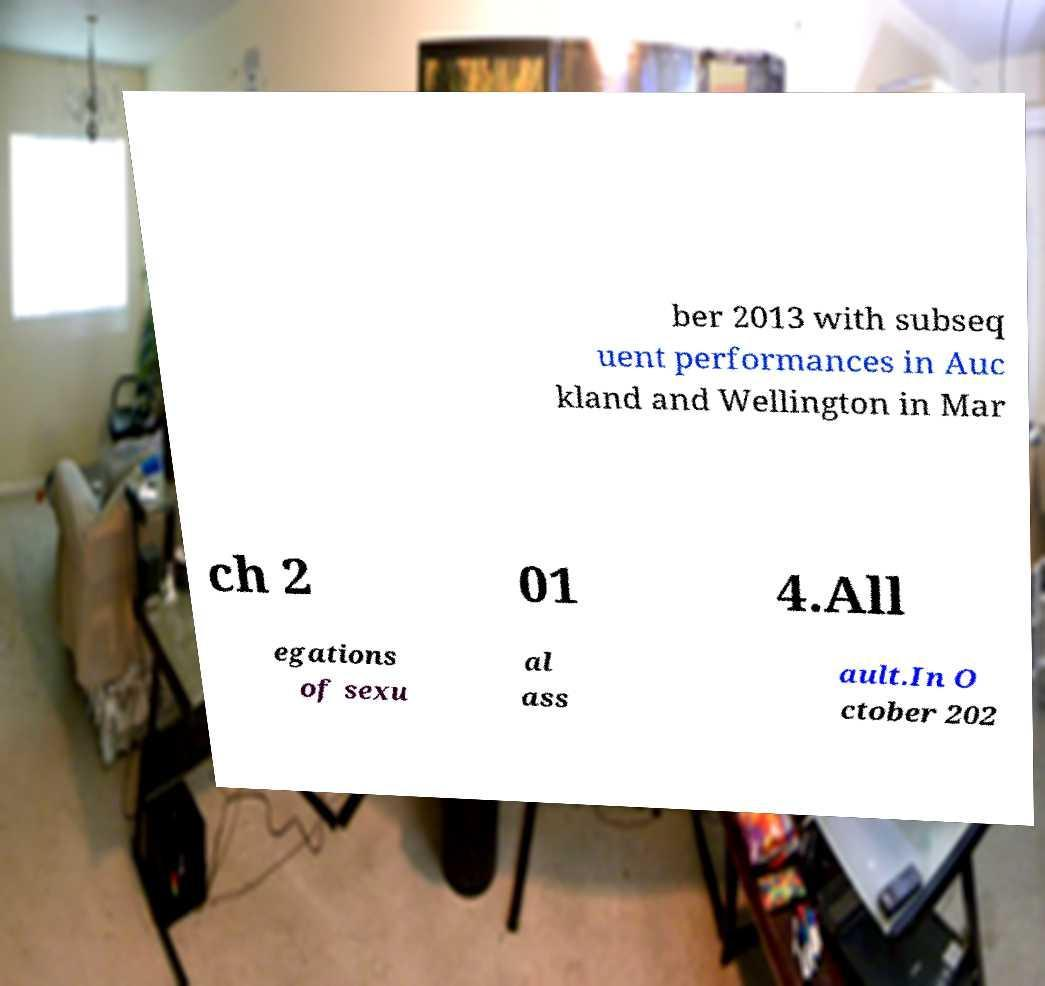There's text embedded in this image that I need extracted. Can you transcribe it verbatim? ber 2013 with subseq uent performances in Auc kland and Wellington in Mar ch 2 01 4.All egations of sexu al ass ault.In O ctober 202 